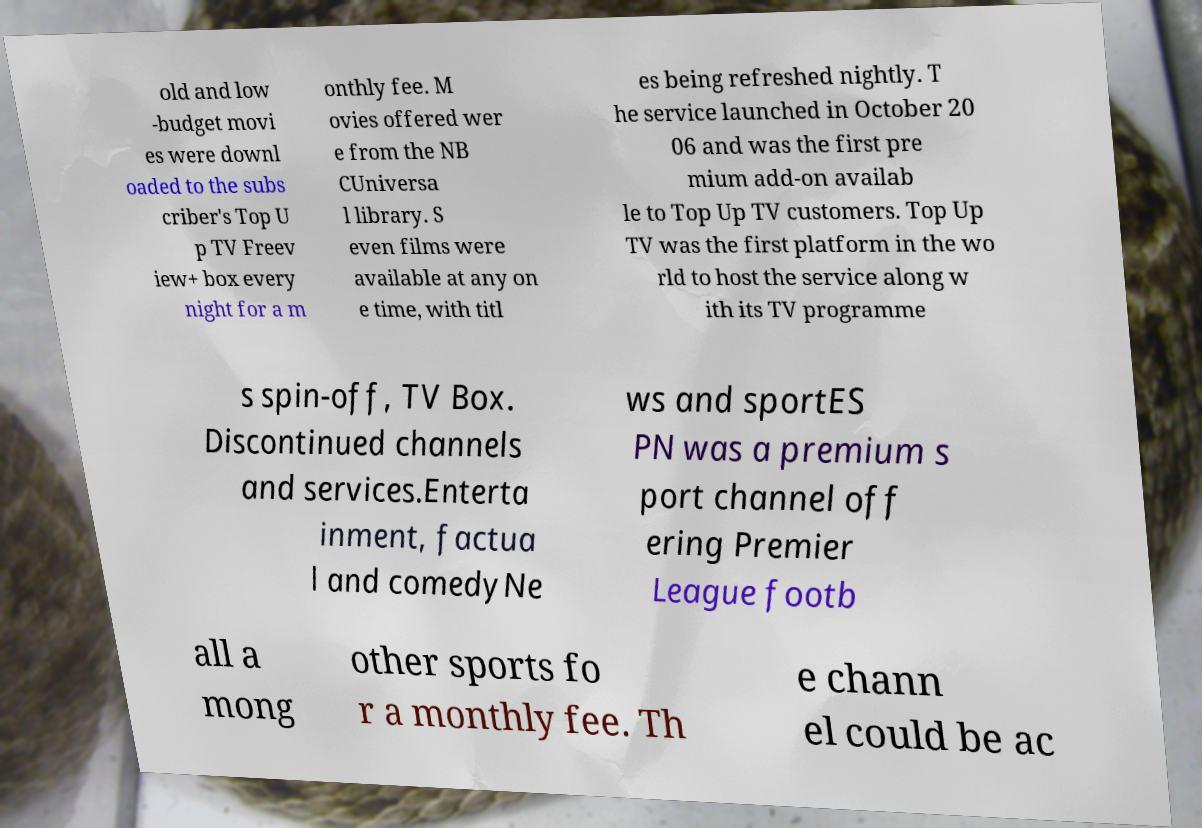Could you assist in decoding the text presented in this image and type it out clearly? old and low -budget movi es were downl oaded to the subs criber's Top U p TV Freev iew+ box every night for a m onthly fee. M ovies offered wer e from the NB CUniversa l library. S even films were available at any on e time, with titl es being refreshed nightly. T he service launched in October 20 06 and was the first pre mium add-on availab le to Top Up TV customers. Top Up TV was the first platform in the wo rld to host the service along w ith its TV programme s spin-off, TV Box. Discontinued channels and services.Enterta inment, factua l and comedyNe ws and sportES PN was a premium s port channel off ering Premier League footb all a mong other sports fo r a monthly fee. Th e chann el could be ac 